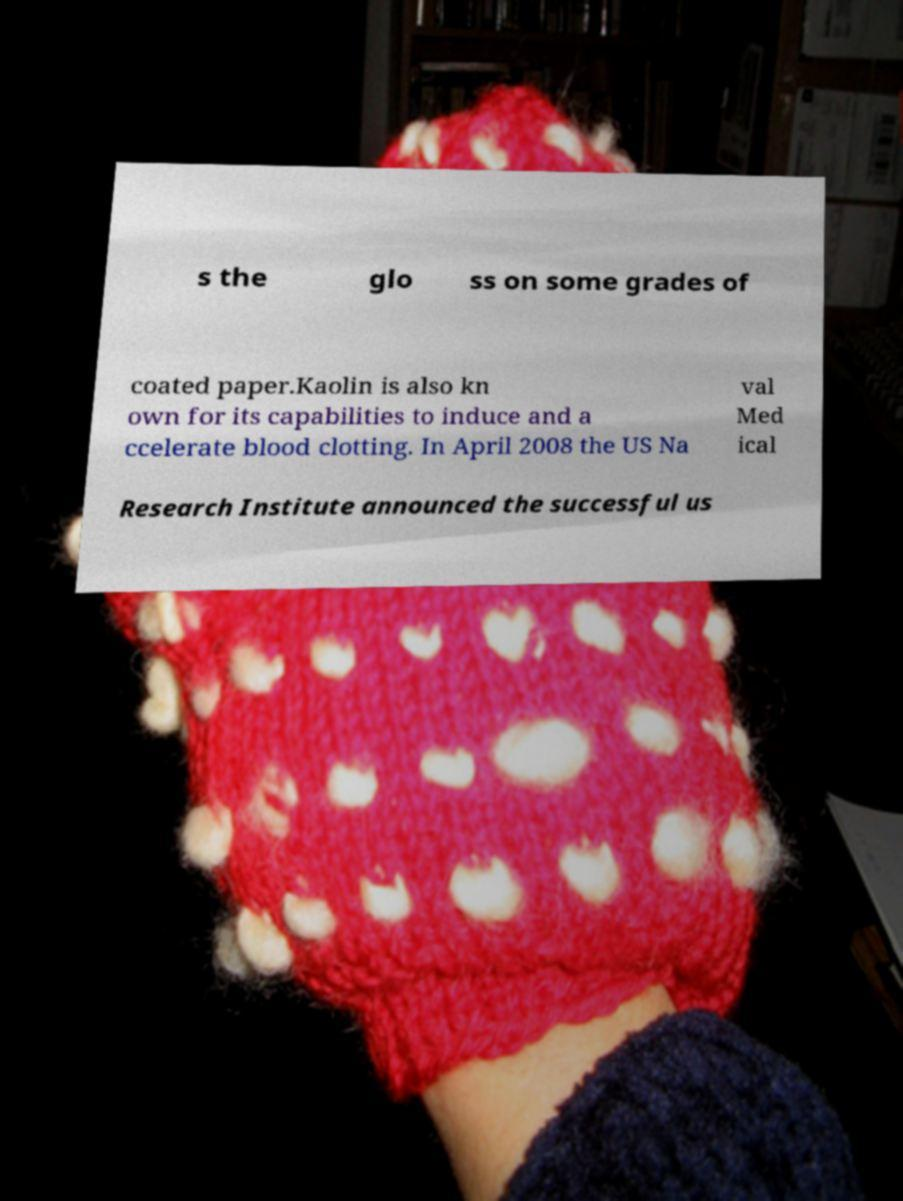Can you accurately transcribe the text from the provided image for me? s the glo ss on some grades of coated paper.Kaolin is also kn own for its capabilities to induce and a ccelerate blood clotting. In April 2008 the US Na val Med ical Research Institute announced the successful us 